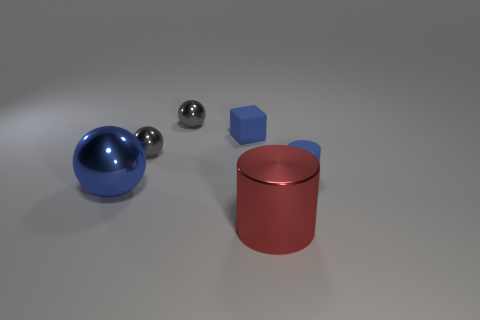Subtract all brown balls. Subtract all blue cubes. How many balls are left? 3 Add 3 large metallic cylinders. How many objects exist? 9 Subtract all cylinders. How many objects are left? 4 Add 3 small blue objects. How many small blue objects exist? 5 Subtract 0 yellow balls. How many objects are left? 6 Subtract all large blue balls. Subtract all red cylinders. How many objects are left? 4 Add 2 small gray metallic things. How many small gray metallic things are left? 4 